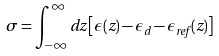<formula> <loc_0><loc_0><loc_500><loc_500>\sigma = \int _ { - \infty } ^ { \infty } d z \left [ \epsilon ( z ) - \epsilon _ { d } - \epsilon _ { r e f } ( z ) \right ]</formula> 